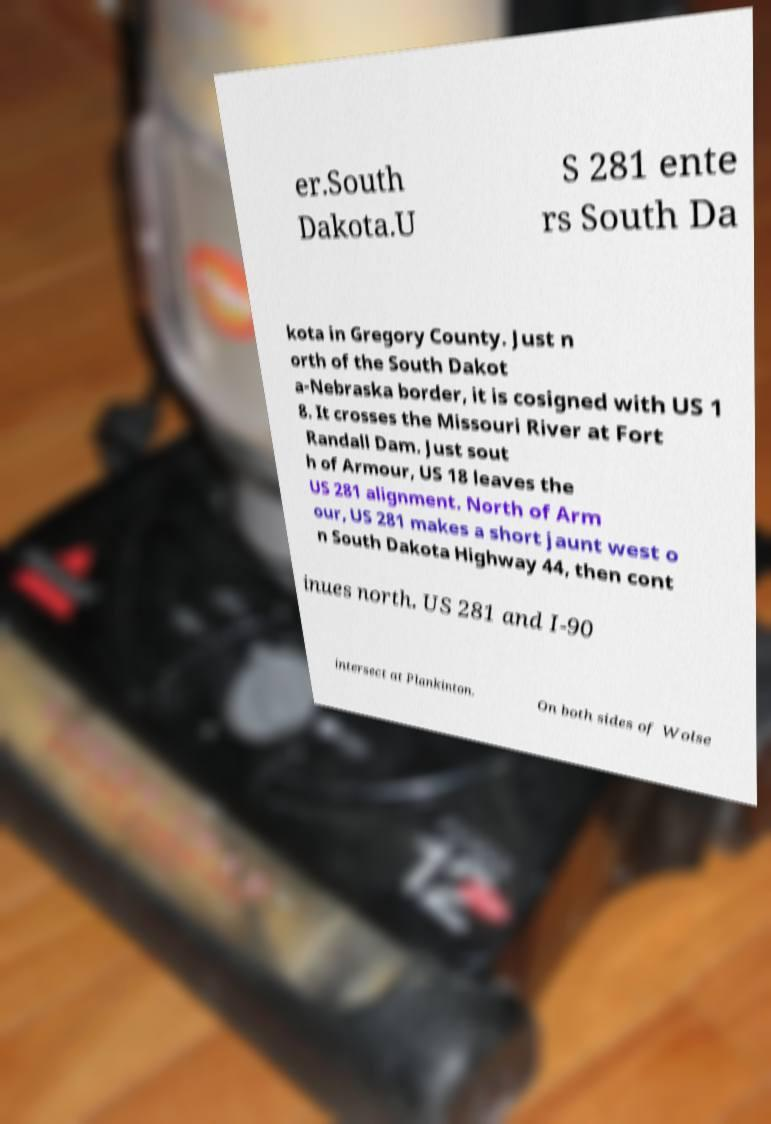There's text embedded in this image that I need extracted. Can you transcribe it verbatim? er.South Dakota.U S 281 ente rs South Da kota in Gregory County. Just n orth of the South Dakot a-Nebraska border, it is cosigned with US 1 8. It crosses the Missouri River at Fort Randall Dam. Just sout h of Armour, US 18 leaves the US 281 alignment. North of Arm our, US 281 makes a short jaunt west o n South Dakota Highway 44, then cont inues north. US 281 and I-90 intersect at Plankinton. On both sides of Wolse 